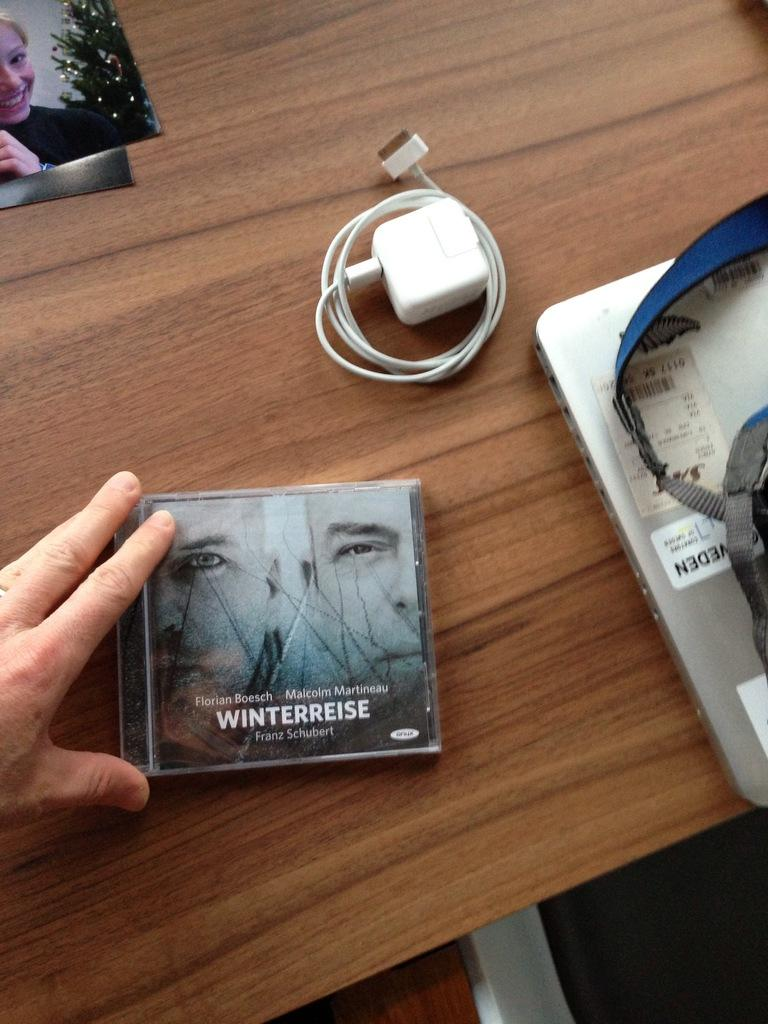<image>
Describe the image concisely. A hand touches a CD case of Winterreise laying on a wooden desk. 